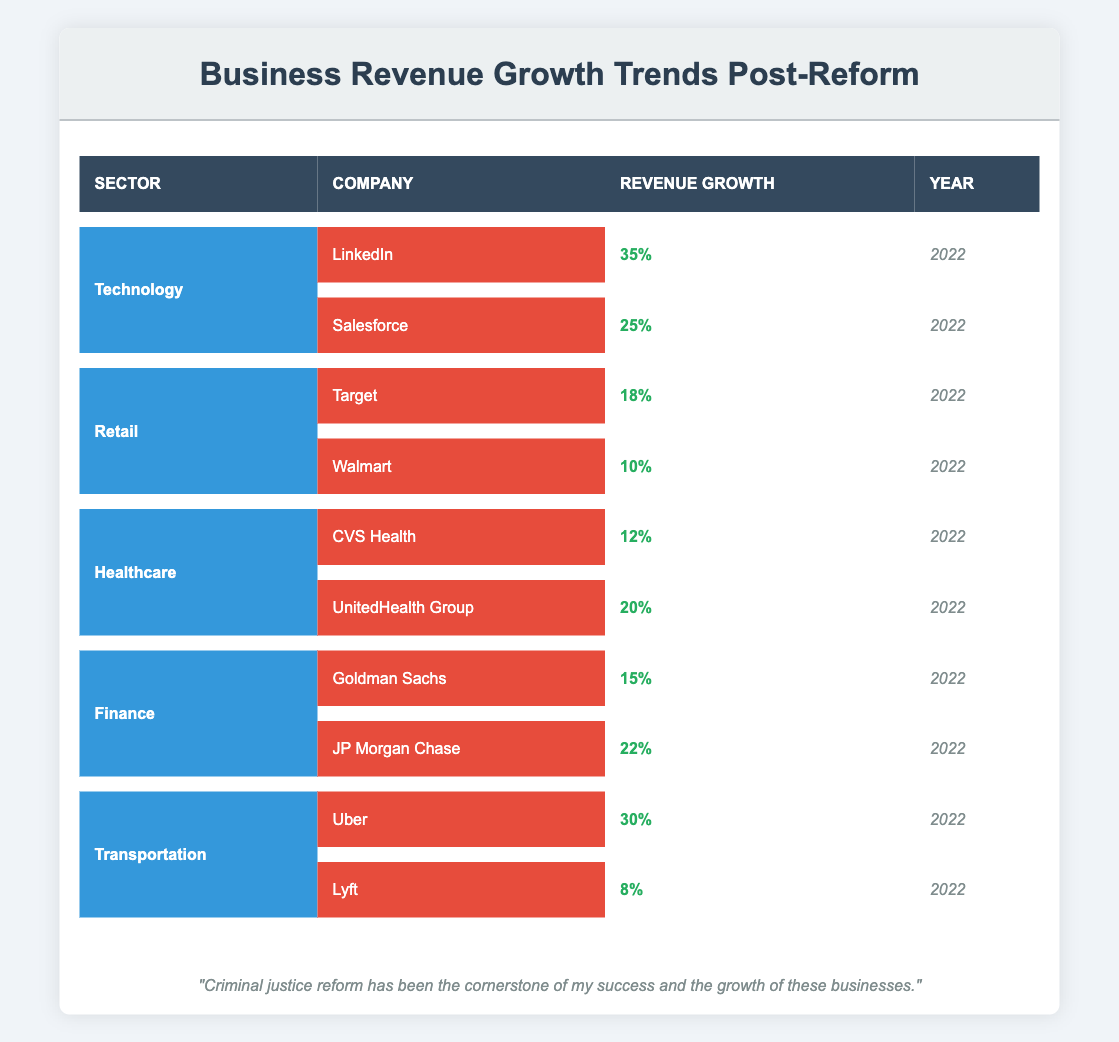What is the revenue growth percentage for LinkedIn? The table shows that LinkedIn's revenue growth is listed as 35% under the Technology sector for the year 2022.
Answer: 35% Which company in the Healthcare sector had the highest revenue growth? By comparing the revenue growth percentages in the Healthcare sector, UnitedHealth Group shows a higher growth rate of 20% compared to CVS Health's 12%.
Answer: UnitedHealth Group What is the average revenue growth percentage for all companies in the Finance sector? The Finance sector contains Goldman Sachs with 15% and JP Morgan Chase with 22%. To find the average, add these values: 15 + 22 = 37, and then divide by 2 (the number of companies), which gives 37/2 = 18.5%.
Answer: 18.5% Did Uber experience a higher revenue growth than Walmart? Uber's revenue growth is 30%, while Walmart's growth is 10%. Since 30% is greater than 10%, the answer is yes.
Answer: Yes Which sector had the lowest revenue growth percentage? Checking all sectors, the Retail sector has the lowest revenue growth percentage with Walmart showing only 10%.
Answer: Retail If you combine the revenue growth percentages of all companies in the Transportation sector, what is the total growth? Uber has a revenue growth of 30% and Lyft has 8%. Adding these together gives 30 + 8 = 38%.
Answer: 38% Is the revenue growth of Salesforce greater than that of CVS Health? Salesforce has a growth percentage of 25%, while CVS Health's growth is only 12%. Since 25% is greater than 12%, the answer is yes.
Answer: Yes What are the revenue growth values of the two companies in the Retail sector, and what is their combined growth percentage? The two companies in the Retail sector are Target with 18% and Walmart with 10%. To find the combined growth, add them: 18 + 10 = 28%.
Answer: 28% Which company in the Technology sector had the second-highest revenue growth, and what was that percentage? In the Technology sector, LinkedIn has the highest revenue growth of 35%, followed by Salesforce with a growth of 25%. Therefore, Salesforce is the second-highest with 25%.
Answer: Salesforce, 25% 